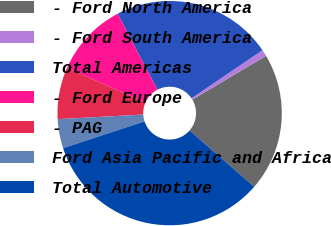Convert chart to OTSL. <chart><loc_0><loc_0><loc_500><loc_500><pie_chart><fcel>- Ford North America<fcel>- Ford South America<fcel>Total Americas<fcel>- Ford Europe<fcel>- PAG<fcel>Ford Asia Pacific and Africa<fcel>Total Automotive<nl><fcel>19.94%<fcel>0.94%<fcel>23.2%<fcel>10.72%<fcel>7.46%<fcel>4.2%<fcel>33.54%<nl></chart> 